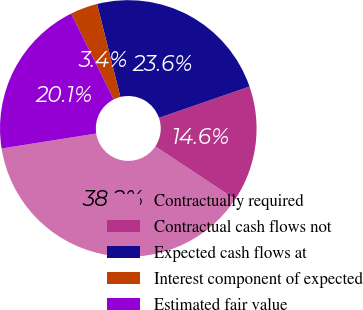<chart> <loc_0><loc_0><loc_500><loc_500><pie_chart><fcel>Contractually required<fcel>Contractual cash flows not<fcel>Expected cash flows at<fcel>Interest component of expected<fcel>Estimated fair value<nl><fcel>38.19%<fcel>14.61%<fcel>23.62%<fcel>3.43%<fcel>20.15%<nl></chart> 